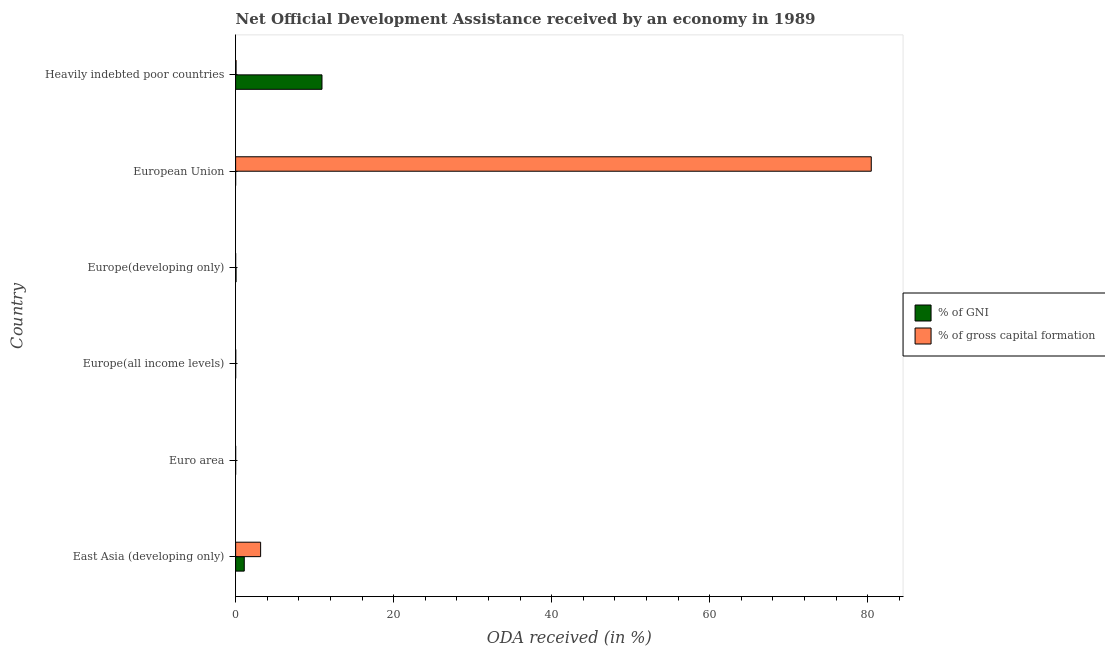Are the number of bars per tick equal to the number of legend labels?
Offer a very short reply. Yes. How many bars are there on the 2nd tick from the top?
Offer a terse response. 2. How many bars are there on the 1st tick from the bottom?
Provide a succinct answer. 2. What is the label of the 3rd group of bars from the top?
Keep it short and to the point. Europe(developing only). In how many cases, is the number of bars for a given country not equal to the number of legend labels?
Make the answer very short. 0. What is the oda received as percentage of gni in East Asia (developing only)?
Offer a terse response. 1.09. Across all countries, what is the maximum oda received as percentage of gross capital formation?
Ensure brevity in your answer.  80.44. Across all countries, what is the minimum oda received as percentage of gross capital formation?
Provide a short and direct response. 0. In which country was the oda received as percentage of gni maximum?
Your response must be concise. Heavily indebted poor countries. In which country was the oda received as percentage of gross capital formation minimum?
Offer a terse response. Europe(developing only). What is the total oda received as percentage of gross capital formation in the graph?
Your response must be concise. 83.68. What is the difference between the oda received as percentage of gni in Europe(all income levels) and that in European Union?
Offer a very short reply. 0. What is the difference between the oda received as percentage of gni in Heavily indebted poor countries and the oda received as percentage of gross capital formation in European Union?
Keep it short and to the point. -69.51. What is the average oda received as percentage of gross capital formation per country?
Keep it short and to the point. 13.95. What is the difference between the oda received as percentage of gni and oda received as percentage of gross capital formation in East Asia (developing only)?
Provide a short and direct response. -2.07. In how many countries, is the oda received as percentage of gross capital formation greater than 48 %?
Make the answer very short. 1. What is the ratio of the oda received as percentage of gni in Euro area to that in Europe(developing only)?
Offer a very short reply. 0.01. Is the difference between the oda received as percentage of gross capital formation in East Asia (developing only) and Europe(developing only) greater than the difference between the oda received as percentage of gni in East Asia (developing only) and Europe(developing only)?
Offer a very short reply. Yes. What is the difference between the highest and the second highest oda received as percentage of gni?
Provide a short and direct response. 9.84. What is the difference between the highest and the lowest oda received as percentage of gni?
Your answer should be compact. 10.93. In how many countries, is the oda received as percentage of gni greater than the average oda received as percentage of gni taken over all countries?
Your answer should be very brief. 1. What does the 1st bar from the top in European Union represents?
Your answer should be compact. % of gross capital formation. What does the 2nd bar from the bottom in Heavily indebted poor countries represents?
Make the answer very short. % of gross capital formation. How many bars are there?
Offer a very short reply. 12. Are all the bars in the graph horizontal?
Provide a succinct answer. Yes. How many countries are there in the graph?
Your response must be concise. 6. Does the graph contain any zero values?
Your response must be concise. No. Where does the legend appear in the graph?
Provide a succinct answer. Center right. How are the legend labels stacked?
Keep it short and to the point. Vertical. What is the title of the graph?
Your answer should be compact. Net Official Development Assistance received by an economy in 1989. Does "Passenger Transport Items" appear as one of the legend labels in the graph?
Your answer should be compact. No. What is the label or title of the X-axis?
Make the answer very short. ODA received (in %). What is the ODA received (in %) of % of GNI in East Asia (developing only)?
Your answer should be compact. 1.09. What is the ODA received (in %) in % of gross capital formation in East Asia (developing only)?
Make the answer very short. 3.16. What is the ODA received (in %) of % of GNI in Euro area?
Offer a very short reply. 0. What is the ODA received (in %) of % of gross capital formation in Euro area?
Your answer should be compact. 0. What is the ODA received (in %) in % of GNI in Europe(all income levels)?
Your response must be concise. 0. What is the ODA received (in %) of % of gross capital formation in Europe(all income levels)?
Your answer should be compact. 0.02. What is the ODA received (in %) of % of GNI in Europe(developing only)?
Provide a short and direct response. 0.06. What is the ODA received (in %) of % of gross capital formation in Europe(developing only)?
Make the answer very short. 0. What is the ODA received (in %) of % of GNI in European Union?
Make the answer very short. 0. What is the ODA received (in %) in % of gross capital formation in European Union?
Ensure brevity in your answer.  80.44. What is the ODA received (in %) of % of GNI in Heavily indebted poor countries?
Your response must be concise. 10.93. What is the ODA received (in %) of % of gross capital formation in Heavily indebted poor countries?
Your answer should be compact. 0.06. Across all countries, what is the maximum ODA received (in %) of % of GNI?
Offer a very short reply. 10.93. Across all countries, what is the maximum ODA received (in %) in % of gross capital formation?
Provide a short and direct response. 80.44. Across all countries, what is the minimum ODA received (in %) in % of GNI?
Provide a short and direct response. 0. Across all countries, what is the minimum ODA received (in %) in % of gross capital formation?
Provide a short and direct response. 0. What is the total ODA received (in %) of % of GNI in the graph?
Offer a very short reply. 12.09. What is the total ODA received (in %) of % of gross capital formation in the graph?
Your answer should be compact. 83.68. What is the difference between the ODA received (in %) in % of GNI in East Asia (developing only) and that in Euro area?
Ensure brevity in your answer.  1.09. What is the difference between the ODA received (in %) in % of gross capital formation in East Asia (developing only) and that in Euro area?
Keep it short and to the point. 3.16. What is the difference between the ODA received (in %) in % of GNI in East Asia (developing only) and that in Europe(all income levels)?
Your answer should be compact. 1.09. What is the difference between the ODA received (in %) in % of gross capital formation in East Asia (developing only) and that in Europe(all income levels)?
Ensure brevity in your answer.  3.15. What is the difference between the ODA received (in %) in % of GNI in East Asia (developing only) and that in Europe(developing only)?
Provide a short and direct response. 1.04. What is the difference between the ODA received (in %) of % of gross capital formation in East Asia (developing only) and that in Europe(developing only)?
Your answer should be very brief. 3.16. What is the difference between the ODA received (in %) in % of GNI in East Asia (developing only) and that in European Union?
Keep it short and to the point. 1.09. What is the difference between the ODA received (in %) in % of gross capital formation in East Asia (developing only) and that in European Union?
Your answer should be compact. -77.28. What is the difference between the ODA received (in %) of % of GNI in East Asia (developing only) and that in Heavily indebted poor countries?
Ensure brevity in your answer.  -9.84. What is the difference between the ODA received (in %) in % of gross capital formation in East Asia (developing only) and that in Heavily indebted poor countries?
Provide a succinct answer. 3.11. What is the difference between the ODA received (in %) in % of GNI in Euro area and that in Europe(all income levels)?
Give a very brief answer. -0. What is the difference between the ODA received (in %) of % of gross capital formation in Euro area and that in Europe(all income levels)?
Your response must be concise. -0.01. What is the difference between the ODA received (in %) in % of GNI in Euro area and that in Europe(developing only)?
Your response must be concise. -0.05. What is the difference between the ODA received (in %) of % of gross capital formation in Euro area and that in Europe(developing only)?
Your answer should be compact. 0. What is the difference between the ODA received (in %) of % of GNI in Euro area and that in European Union?
Your answer should be compact. 0. What is the difference between the ODA received (in %) of % of gross capital formation in Euro area and that in European Union?
Offer a very short reply. -80.44. What is the difference between the ODA received (in %) in % of GNI in Euro area and that in Heavily indebted poor countries?
Your answer should be compact. -10.93. What is the difference between the ODA received (in %) of % of gross capital formation in Euro area and that in Heavily indebted poor countries?
Your answer should be compact. -0.05. What is the difference between the ODA received (in %) in % of GNI in Europe(all income levels) and that in Europe(developing only)?
Provide a short and direct response. -0.05. What is the difference between the ODA received (in %) of % of gross capital formation in Europe(all income levels) and that in Europe(developing only)?
Ensure brevity in your answer.  0.01. What is the difference between the ODA received (in %) of % of GNI in Europe(all income levels) and that in European Union?
Provide a short and direct response. 0. What is the difference between the ODA received (in %) in % of gross capital formation in Europe(all income levels) and that in European Union?
Provide a short and direct response. -80.42. What is the difference between the ODA received (in %) of % of GNI in Europe(all income levels) and that in Heavily indebted poor countries?
Your response must be concise. -10.93. What is the difference between the ODA received (in %) of % of gross capital formation in Europe(all income levels) and that in Heavily indebted poor countries?
Provide a succinct answer. -0.04. What is the difference between the ODA received (in %) in % of GNI in Europe(developing only) and that in European Union?
Offer a very short reply. 0.05. What is the difference between the ODA received (in %) in % of gross capital formation in Europe(developing only) and that in European Union?
Ensure brevity in your answer.  -80.44. What is the difference between the ODA received (in %) in % of GNI in Europe(developing only) and that in Heavily indebted poor countries?
Keep it short and to the point. -10.87. What is the difference between the ODA received (in %) in % of gross capital formation in Europe(developing only) and that in Heavily indebted poor countries?
Offer a terse response. -0.05. What is the difference between the ODA received (in %) in % of GNI in European Union and that in Heavily indebted poor countries?
Your answer should be compact. -10.93. What is the difference between the ODA received (in %) of % of gross capital formation in European Union and that in Heavily indebted poor countries?
Keep it short and to the point. 80.38. What is the difference between the ODA received (in %) of % of GNI in East Asia (developing only) and the ODA received (in %) of % of gross capital formation in Euro area?
Ensure brevity in your answer.  1.09. What is the difference between the ODA received (in %) in % of GNI in East Asia (developing only) and the ODA received (in %) in % of gross capital formation in Europe(all income levels)?
Ensure brevity in your answer.  1.08. What is the difference between the ODA received (in %) of % of GNI in East Asia (developing only) and the ODA received (in %) of % of gross capital formation in Europe(developing only)?
Offer a very short reply. 1.09. What is the difference between the ODA received (in %) in % of GNI in East Asia (developing only) and the ODA received (in %) in % of gross capital formation in European Union?
Make the answer very short. -79.35. What is the difference between the ODA received (in %) of % of GNI in East Asia (developing only) and the ODA received (in %) of % of gross capital formation in Heavily indebted poor countries?
Offer a terse response. 1.04. What is the difference between the ODA received (in %) in % of GNI in Euro area and the ODA received (in %) in % of gross capital formation in Europe(all income levels)?
Provide a short and direct response. -0.02. What is the difference between the ODA received (in %) of % of GNI in Euro area and the ODA received (in %) of % of gross capital formation in Europe(developing only)?
Keep it short and to the point. -0. What is the difference between the ODA received (in %) of % of GNI in Euro area and the ODA received (in %) of % of gross capital formation in European Union?
Keep it short and to the point. -80.44. What is the difference between the ODA received (in %) in % of GNI in Euro area and the ODA received (in %) in % of gross capital formation in Heavily indebted poor countries?
Your answer should be very brief. -0.06. What is the difference between the ODA received (in %) in % of GNI in Europe(all income levels) and the ODA received (in %) in % of gross capital formation in Europe(developing only)?
Make the answer very short. 0. What is the difference between the ODA received (in %) in % of GNI in Europe(all income levels) and the ODA received (in %) in % of gross capital formation in European Union?
Make the answer very short. -80.44. What is the difference between the ODA received (in %) in % of GNI in Europe(all income levels) and the ODA received (in %) in % of gross capital formation in Heavily indebted poor countries?
Your response must be concise. -0.05. What is the difference between the ODA received (in %) in % of GNI in Europe(developing only) and the ODA received (in %) in % of gross capital formation in European Union?
Offer a very short reply. -80.38. What is the difference between the ODA received (in %) in % of GNI in Europe(developing only) and the ODA received (in %) in % of gross capital formation in Heavily indebted poor countries?
Your response must be concise. -0. What is the difference between the ODA received (in %) in % of GNI in European Union and the ODA received (in %) in % of gross capital formation in Heavily indebted poor countries?
Keep it short and to the point. -0.06. What is the average ODA received (in %) in % of GNI per country?
Give a very brief answer. 2.01. What is the average ODA received (in %) in % of gross capital formation per country?
Your response must be concise. 13.95. What is the difference between the ODA received (in %) in % of GNI and ODA received (in %) in % of gross capital formation in East Asia (developing only)?
Your response must be concise. -2.07. What is the difference between the ODA received (in %) in % of GNI and ODA received (in %) in % of gross capital formation in Euro area?
Your answer should be very brief. -0. What is the difference between the ODA received (in %) in % of GNI and ODA received (in %) in % of gross capital formation in Europe(all income levels)?
Offer a very short reply. -0.01. What is the difference between the ODA received (in %) in % of GNI and ODA received (in %) in % of gross capital formation in Europe(developing only)?
Your response must be concise. 0.05. What is the difference between the ODA received (in %) in % of GNI and ODA received (in %) in % of gross capital formation in European Union?
Ensure brevity in your answer.  -80.44. What is the difference between the ODA received (in %) in % of GNI and ODA received (in %) in % of gross capital formation in Heavily indebted poor countries?
Your response must be concise. 10.87. What is the ratio of the ODA received (in %) of % of GNI in East Asia (developing only) to that in Euro area?
Give a very brief answer. 1444.37. What is the ratio of the ODA received (in %) of % of gross capital formation in East Asia (developing only) to that in Euro area?
Keep it short and to the point. 1008.72. What is the ratio of the ODA received (in %) in % of GNI in East Asia (developing only) to that in Europe(all income levels)?
Offer a very short reply. 257.97. What is the ratio of the ODA received (in %) in % of gross capital formation in East Asia (developing only) to that in Europe(all income levels)?
Keep it short and to the point. 190.71. What is the ratio of the ODA received (in %) of % of GNI in East Asia (developing only) to that in Europe(developing only)?
Provide a short and direct response. 19.7. What is the ratio of the ODA received (in %) in % of gross capital formation in East Asia (developing only) to that in Europe(developing only)?
Offer a terse response. 1333.85. What is the ratio of the ODA received (in %) in % of GNI in East Asia (developing only) to that in European Union?
Keep it short and to the point. 1877.47. What is the ratio of the ODA received (in %) of % of gross capital formation in East Asia (developing only) to that in European Union?
Keep it short and to the point. 0.04. What is the ratio of the ODA received (in %) of % of GNI in East Asia (developing only) to that in Heavily indebted poor countries?
Your response must be concise. 0.1. What is the ratio of the ODA received (in %) of % of gross capital formation in East Asia (developing only) to that in Heavily indebted poor countries?
Keep it short and to the point. 56.54. What is the ratio of the ODA received (in %) of % of GNI in Euro area to that in Europe(all income levels)?
Your answer should be very brief. 0.18. What is the ratio of the ODA received (in %) of % of gross capital formation in Euro area to that in Europe(all income levels)?
Ensure brevity in your answer.  0.19. What is the ratio of the ODA received (in %) in % of GNI in Euro area to that in Europe(developing only)?
Give a very brief answer. 0.01. What is the ratio of the ODA received (in %) of % of gross capital formation in Euro area to that in Europe(developing only)?
Give a very brief answer. 1.32. What is the ratio of the ODA received (in %) of % of GNI in Euro area to that in European Union?
Your response must be concise. 1.3. What is the ratio of the ODA received (in %) in % of gross capital formation in Euro area to that in European Union?
Keep it short and to the point. 0. What is the ratio of the ODA received (in %) in % of GNI in Euro area to that in Heavily indebted poor countries?
Your response must be concise. 0. What is the ratio of the ODA received (in %) of % of gross capital formation in Euro area to that in Heavily indebted poor countries?
Ensure brevity in your answer.  0.06. What is the ratio of the ODA received (in %) in % of GNI in Europe(all income levels) to that in Europe(developing only)?
Your answer should be compact. 0.08. What is the ratio of the ODA received (in %) of % of gross capital formation in Europe(all income levels) to that in Europe(developing only)?
Offer a very short reply. 6.99. What is the ratio of the ODA received (in %) of % of GNI in Europe(all income levels) to that in European Union?
Your answer should be compact. 7.28. What is the ratio of the ODA received (in %) in % of GNI in Europe(all income levels) to that in Heavily indebted poor countries?
Keep it short and to the point. 0. What is the ratio of the ODA received (in %) in % of gross capital formation in Europe(all income levels) to that in Heavily indebted poor countries?
Provide a short and direct response. 0.3. What is the ratio of the ODA received (in %) of % of GNI in Europe(developing only) to that in European Union?
Ensure brevity in your answer.  95.31. What is the ratio of the ODA received (in %) in % of gross capital formation in Europe(developing only) to that in European Union?
Your response must be concise. 0. What is the ratio of the ODA received (in %) in % of GNI in Europe(developing only) to that in Heavily indebted poor countries?
Give a very brief answer. 0.01. What is the ratio of the ODA received (in %) in % of gross capital formation in Europe(developing only) to that in Heavily indebted poor countries?
Ensure brevity in your answer.  0.04. What is the ratio of the ODA received (in %) of % of gross capital formation in European Union to that in Heavily indebted poor countries?
Ensure brevity in your answer.  1437.46. What is the difference between the highest and the second highest ODA received (in %) of % of GNI?
Your answer should be compact. 9.84. What is the difference between the highest and the second highest ODA received (in %) of % of gross capital formation?
Ensure brevity in your answer.  77.28. What is the difference between the highest and the lowest ODA received (in %) in % of GNI?
Keep it short and to the point. 10.93. What is the difference between the highest and the lowest ODA received (in %) of % of gross capital formation?
Offer a very short reply. 80.44. 